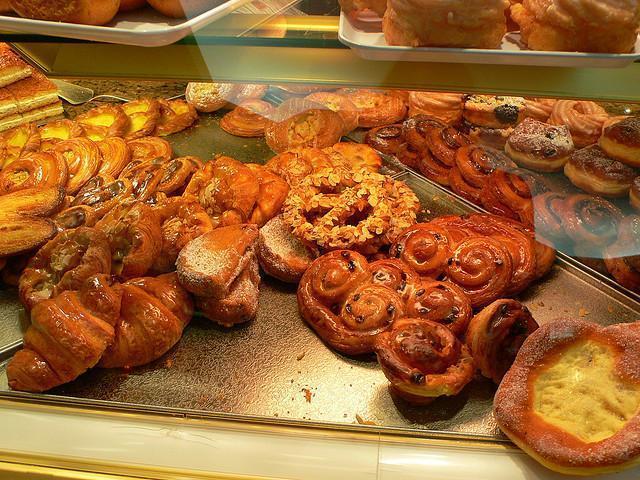How many donuts are there?
Give a very brief answer. 8. How many people are on the ground?
Give a very brief answer. 0. 